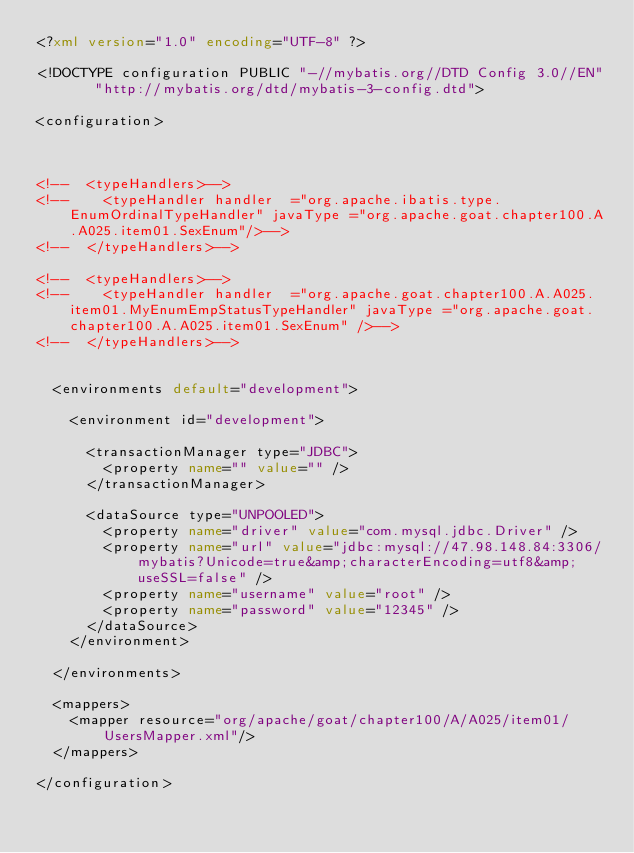<code> <loc_0><loc_0><loc_500><loc_500><_XML_><?xml version="1.0" encoding="UTF-8" ?>

<!DOCTYPE configuration PUBLIC "-//mybatis.org//DTD Config 3.0//EN"   "http://mybatis.org/dtd/mybatis-3-config.dtd">

<configuration>



<!--  <typeHandlers>-->
<!--    <typeHandler handler  ="org.apache.ibatis.type.EnumOrdinalTypeHandler" javaType ="org.apache.goat.chapter100.A.A025.item01.SexEnum"/>-->
<!--  </typeHandlers>-->

<!--  <typeHandlers>-->
<!--    <typeHandler handler  ="org.apache.goat.chapter100.A.A025.item01.MyEnumEmpStatusTypeHandler" javaType ="org.apache.goat.chapter100.A.A025.item01.SexEnum" />-->
<!--  </typeHandlers>-->


  <environments default="development">

    <environment id="development">

      <transactionManager type="JDBC">
        <property name="" value="" />
      </transactionManager>

      <dataSource type="UNPOOLED">
        <property name="driver" value="com.mysql.jdbc.Driver" />
        <property name="url" value="jdbc:mysql://47.98.148.84:3306/mybatis?Unicode=true&amp;characterEncoding=utf8&amp;useSSL=false" />
        <property name="username" value="root" />
        <property name="password" value="12345" />
      </dataSource>
    </environment>

  </environments>

  <mappers>
    <mapper resource="org/apache/goat/chapter100/A/A025/item01/UsersMapper.xml"/>
  </mappers>

</configuration>


</code> 